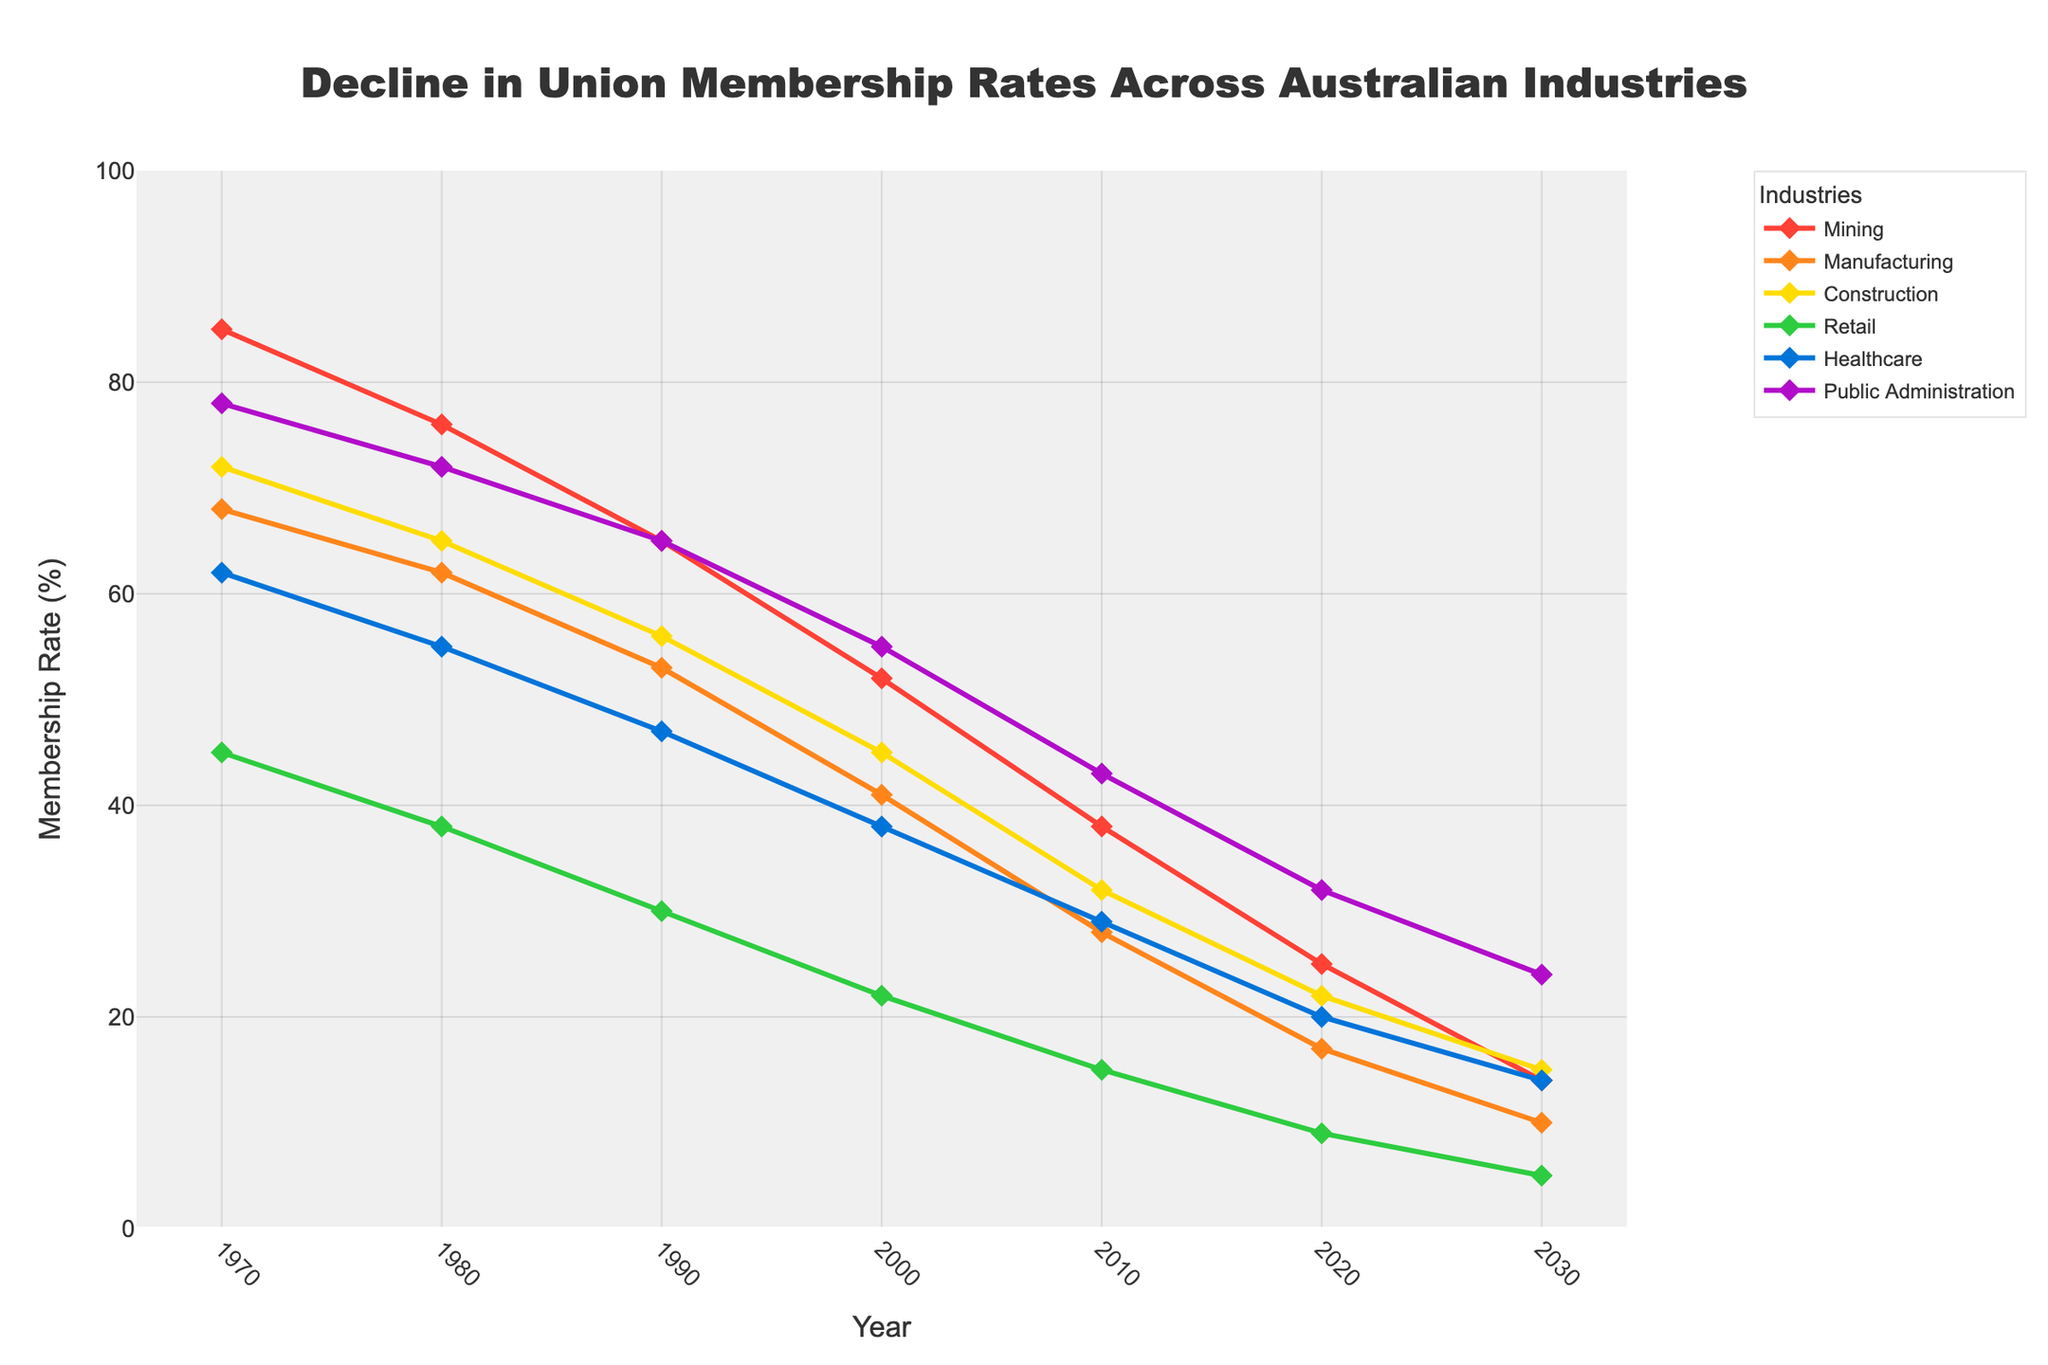what was the rate of union membership in the mining industry in 1970? In the line chart, look at the value point for the year 1970 on the line representing the mining industry (red line). It is clearly marked at 85.
Answer: 85% which industry had the highest union membership rate in 2020? Look at the data points for all industries in 2020 and compare their values. The public administration industry has the highest value at 32%.
Answer: Public Administration what is the difference in union membership rates between the public administration and retail industries in 2020? Find the data points for both public administration and retail industries in 2020. Subtract the retail value (9) from the public administration value (32).
Answer: 23% how has the union membership rate in the healthcare industry changed from 1970 to 2030? Locate the data points for healthcare in 1970 (62) and in 2030 (14). Subtract the 2030 value from the 1970 value.
Answer: Decreased by 48 points which industry has shown the most significant decrease in union membership rates over the past 50 years? Compare the differences in rates from 1970 to 2020 for all industries. The largest decrease can be observed in the mining industry, from 85% to 14%.
Answer: Mining how does the membership rate for the construction industry in 1980 compare to that in 2020? Find the data points for the construction industry for the years 1980 (65) and 2020 (22). Compare the two values.
Answer: It decreased from 65% to 22% which industry experienced the smallest change in union membership rates between 1970 and 2030? Calculate the change for each industry by subtracting the 2030 value from the 1970 value. The smallest change is seen in retail, decreasing from 45 to 5.
Answer: Retail (40 points) what was the average union membership rate across all industries in 1990? Find the data points for all industries in 1990 (Mining: 65, Manufacturing: 53, Construction: 56, Retail: 30, Healthcare: 47, Public Administration: 65). Sum them up and divide by the number of industries (6). (65 + 53 + 56 + 30 + 47 + 65) / 6 = 52.67
Answer: 52.67% compare the union membership rates in 2000 between healthcare and manufacturing. Find the data points for healthcare (38) and manufacturing (41) in 2000. Compare the two values.
Answer: Manufacturing had a higher rate at 41% compared to healthcare's 38% what trend can be observed for the union membership rates in the public administration industry from 1970 to 2030? Observe the line for public administration, which decreases consistently from 1970 (78) to 2030 (24).
Answer: Consistent decline 